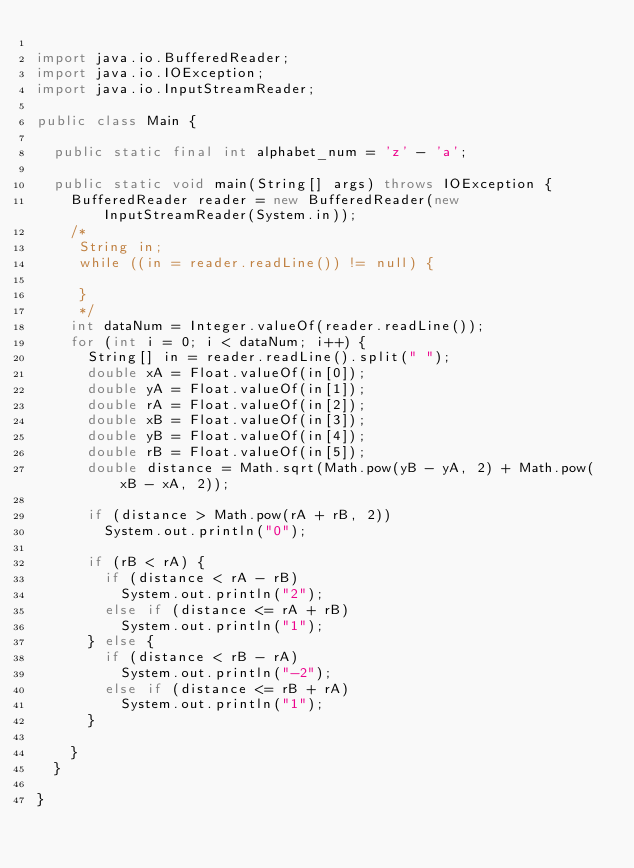<code> <loc_0><loc_0><loc_500><loc_500><_Java_>
import java.io.BufferedReader;
import java.io.IOException;
import java.io.InputStreamReader;

public class Main {

  public static final int alphabet_num = 'z' - 'a';

  public static void main(String[] args) throws IOException {
    BufferedReader reader = new BufferedReader(new InputStreamReader(System.in));
    /*
     String in;
     while ((in = reader.readLine()) != null) {

     }
     */
    int dataNum = Integer.valueOf(reader.readLine());
    for (int i = 0; i < dataNum; i++) {
      String[] in = reader.readLine().split(" ");
      double xA = Float.valueOf(in[0]);
      double yA = Float.valueOf(in[1]);
      double rA = Float.valueOf(in[2]);
      double xB = Float.valueOf(in[3]);
      double yB = Float.valueOf(in[4]);
      double rB = Float.valueOf(in[5]);
      double distance = Math.sqrt(Math.pow(yB - yA, 2) + Math.pow(xB - xA, 2));

      if (distance > Math.pow(rA + rB, 2))
        System.out.println("0");

      if (rB < rA) {
        if (distance < rA - rB)
          System.out.println("2");
        else if (distance <= rA + rB)
          System.out.println("1");
      } else {
        if (distance < rB - rA)
          System.out.println("-2");
        else if (distance <= rB + rA)
          System.out.println("1");
      }

    }
  }

}</code> 